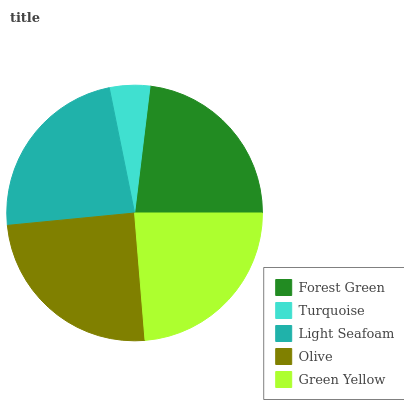Is Turquoise the minimum?
Answer yes or no. Yes. Is Olive the maximum?
Answer yes or no. Yes. Is Light Seafoam the minimum?
Answer yes or no. No. Is Light Seafoam the maximum?
Answer yes or no. No. Is Light Seafoam greater than Turquoise?
Answer yes or no. Yes. Is Turquoise less than Light Seafoam?
Answer yes or no. Yes. Is Turquoise greater than Light Seafoam?
Answer yes or no. No. Is Light Seafoam less than Turquoise?
Answer yes or no. No. Is Light Seafoam the high median?
Answer yes or no. Yes. Is Light Seafoam the low median?
Answer yes or no. Yes. Is Turquoise the high median?
Answer yes or no. No. Is Olive the low median?
Answer yes or no. No. 